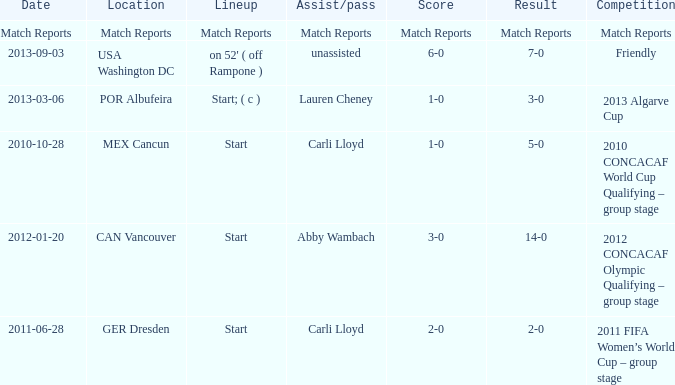Where has a score of match reports? Match Reports. 